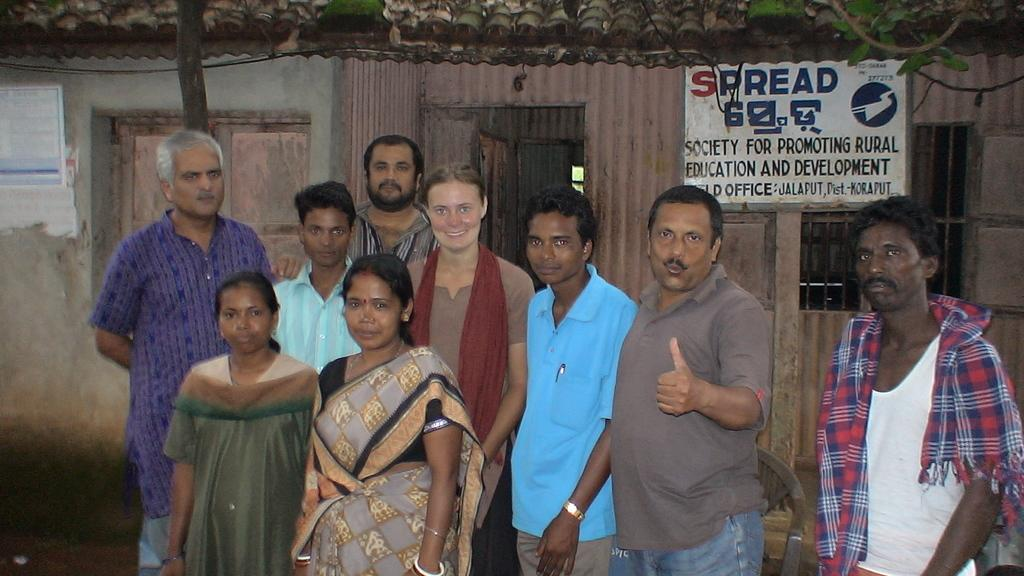How many people are in the image? There is a group of people in the image, but the exact number cannot be determined from the provided facts. What can be seen in the background of the image? There is a house in the background of the image. What is on the house? The house has a board. What is in front of the house? There are cables and a branch in front of the house. What type of ticket is being handed out to the people in the image? There is no mention of a ticket or any activity involving tickets in the image. 